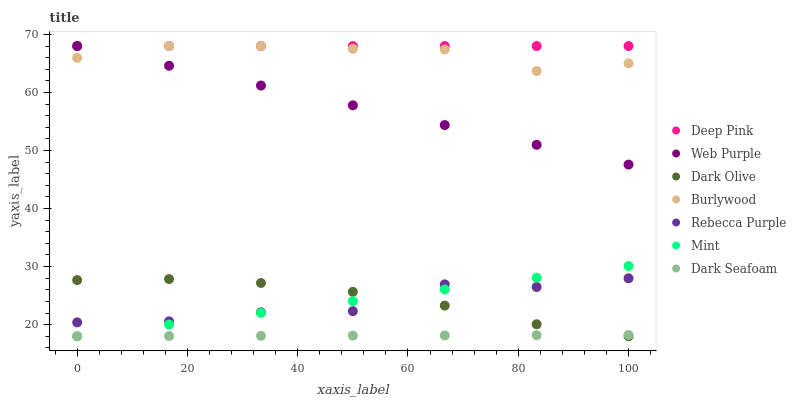Does Dark Seafoam have the minimum area under the curve?
Answer yes or no. Yes. Does Deep Pink have the maximum area under the curve?
Answer yes or no. Yes. Does Burlywood have the minimum area under the curve?
Answer yes or no. No. Does Burlywood have the maximum area under the curve?
Answer yes or no. No. Is Deep Pink the smoothest?
Answer yes or no. Yes. Is Rebecca Purple the roughest?
Answer yes or no. Yes. Is Burlywood the smoothest?
Answer yes or no. No. Is Burlywood the roughest?
Answer yes or no. No. Does Dark Olive have the lowest value?
Answer yes or no. Yes. Does Burlywood have the lowest value?
Answer yes or no. No. Does Web Purple have the highest value?
Answer yes or no. Yes. Does Dark Olive have the highest value?
Answer yes or no. No. Is Dark Olive less than Deep Pink?
Answer yes or no. Yes. Is Deep Pink greater than Rebecca Purple?
Answer yes or no. Yes. Does Deep Pink intersect Burlywood?
Answer yes or no. Yes. Is Deep Pink less than Burlywood?
Answer yes or no. No. Is Deep Pink greater than Burlywood?
Answer yes or no. No. Does Dark Olive intersect Deep Pink?
Answer yes or no. No. 